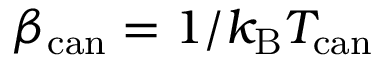Convert formula to latex. <formula><loc_0><loc_0><loc_500><loc_500>\beta _ { c a n } = 1 / k _ { B } T _ { c a n }</formula> 